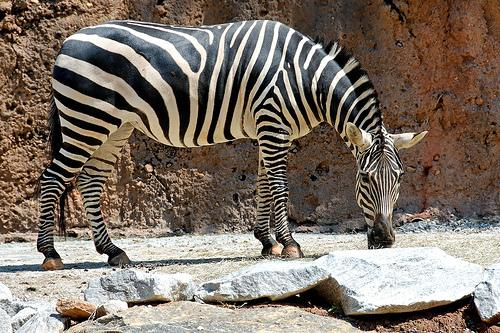Question: when was the pic taken?
Choices:
A. At night.
B. In the evening.
C. During the day.
D. In the early morning.
Answer with the letter. Answer: C Question: what is the color of the animal?
Choices:
A. Brown.
B. Grey.
C. Black and white.
D. Tan.
Answer with the letter. Answer: C Question: what is the animal doing?
Choices:
A. Eating.
B. Playing.
C. Sleeping.
D. Looking at the camera.
Answer with the letter. Answer: A Question: where was the pic taken from?
Choices:
A. Zoo.
B. Museum.
C. A concert.
D. An amusement park.
Answer with the letter. Answer: A 